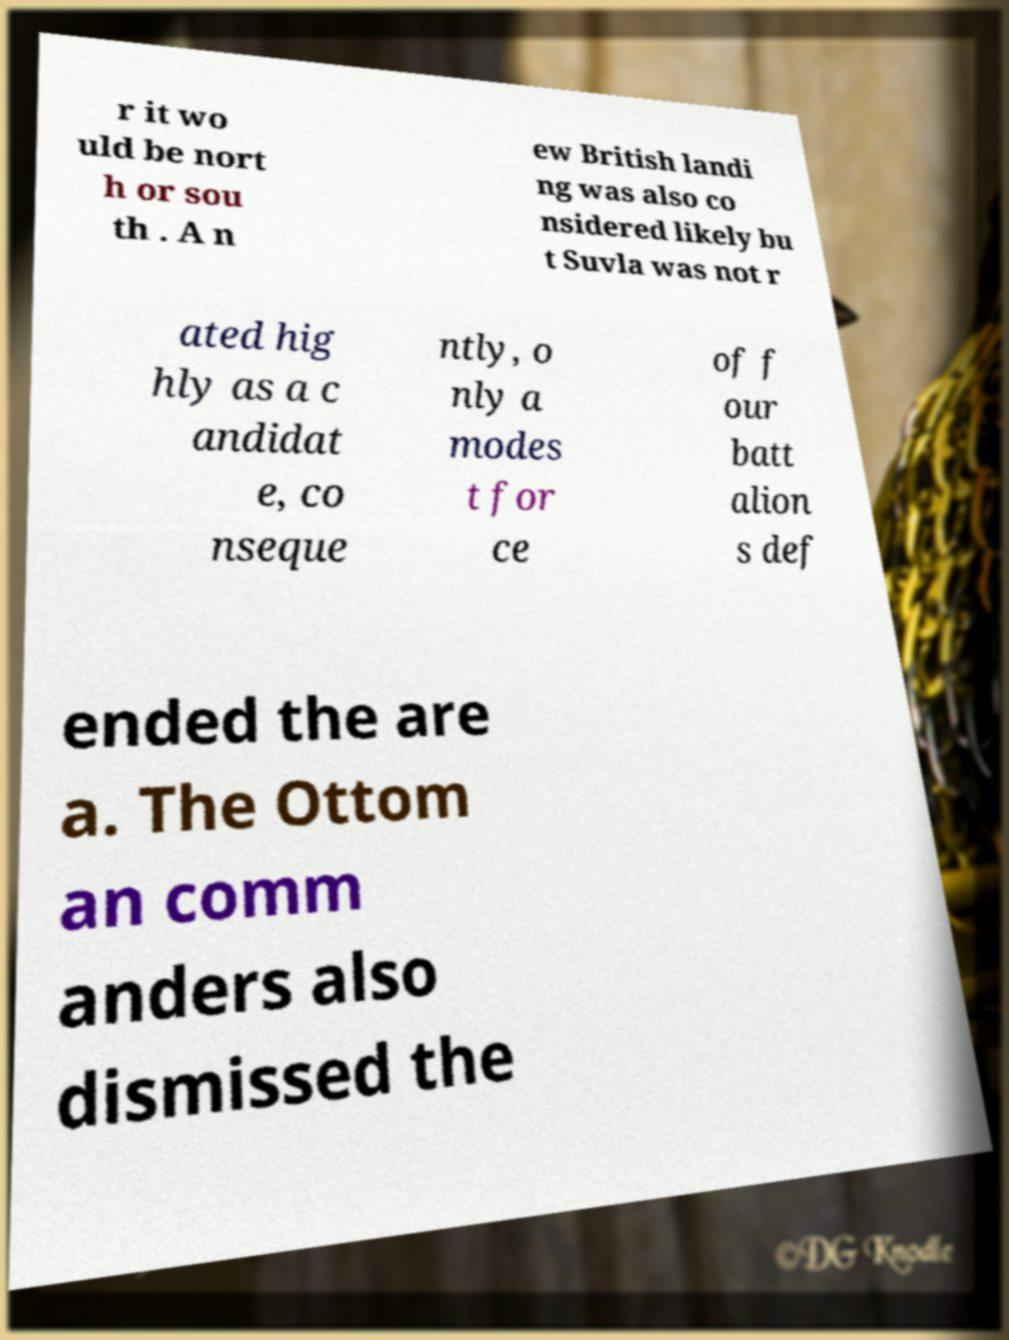Can you read and provide the text displayed in the image?This photo seems to have some interesting text. Can you extract and type it out for me? r it wo uld be nort h or sou th . A n ew British landi ng was also co nsidered likely bu t Suvla was not r ated hig hly as a c andidat e, co nseque ntly, o nly a modes t for ce of f our batt alion s def ended the are a. The Ottom an comm anders also dismissed the 